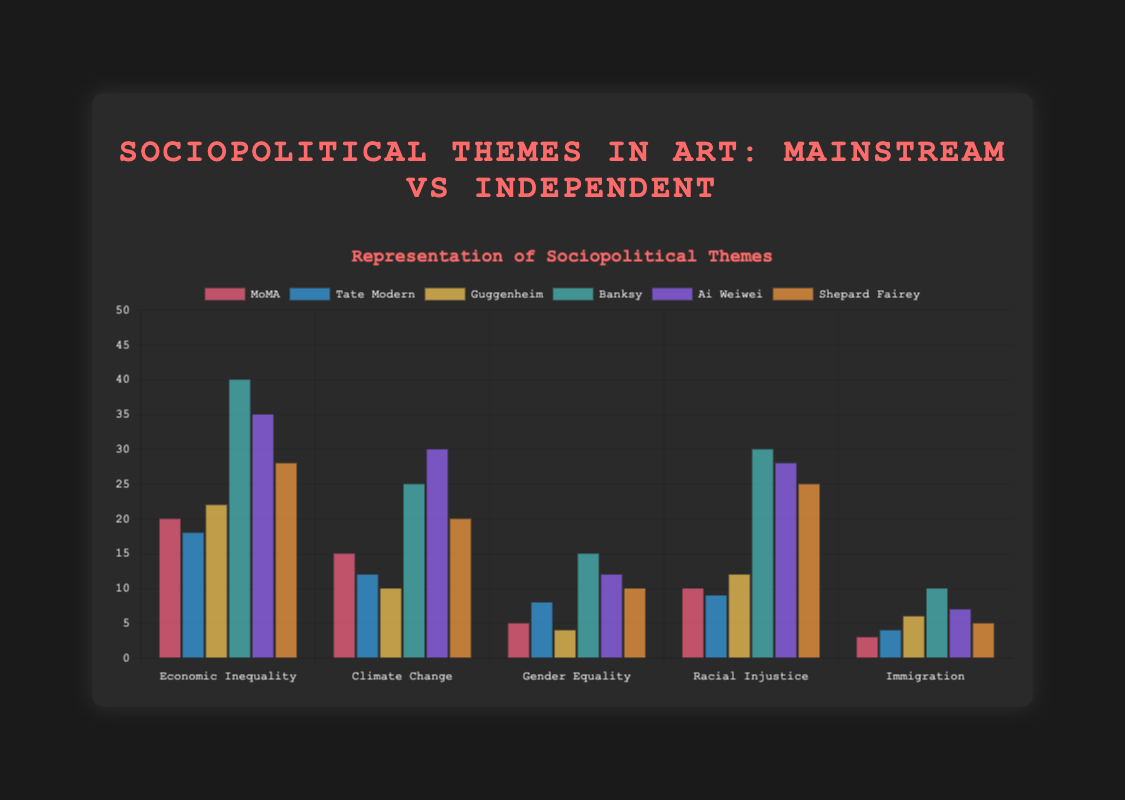What's the difference in the representation of "Economic Inequality" between MoMA and Banksy? MoMA's representation of "Economic Inequality" is 20, while Banksy's is 40. The difference is calculated by subtracting MoMA’s value from Banksy's value: 40 - 20 = 20.
Answer: 20 Which institution represents "Gender Equality" the least? By comparing the values for "Gender Equality" across all institutions, MoMA has a value of 5, Tate Modern 8, Guggenheim 4, Banksy 15, Ai Weiwei 12, and Shepard Fairey 10. Guggenheim has the lowest value of 4.
Answer: Guggenheim What's the total representation of "Climate Change" in Independent Art? Summing up the values of "Climate Change" for all Independent Art categories: Banksy (25) + Ai Weiwei (30) + Shepard Fairey (20) = 75.
Answer: 75 Is the representation of "Racial Injustice" by Shepard Fairey greater than or equal to that by Tate Modern? Shepard Fairey has a representation of 25 for "Racial Injustice", while Tate Modern has 9. Since 25 is greater than 9, the answer is "greater than."
Answer: Greater than What is the average representation of "Immigration" across all Mainstream Art institutions? Sum the "Immigration" values for MoMA (3), Tate Modern (4), and Guggenheim (6): 3 + 4 + 6 = 13. Then, divide by the number of institutions (3): 13 / 3 ≈ 4.33.
Answer: 4.33 Which institution has the lowest representation of "Economic Inequality"? Compare the values for "Economic Inequality": MoMA (20), Tate Modern (18), Guggenheim (22), Banksy (40), Ai Weiwei (35), Shepard Fairey (28). The lowest value is 18 from Tate Modern.
Answer: Tate Modern Among Banksy, Ai Weiwei, and Shepard Fairey, who has the highest representation for "Gender Equality"? Comparing the values for "Gender Equality" across Banksy (15), Ai Weiwei (12), and Shepard Fairey (10), Banksy has the highest representation with 15.
Answer: Banksy Is Ai Weiwei's representation of "Climate Change" higher than MoMA's representation of "Racial Injustice"? Ai Weiwei's representation for "Climate Change" is 30, while MoMA’s representation for "Racial Injustice" is 10. Since 30 is greater than 10, the answer is "yes."
Answer: Yes 